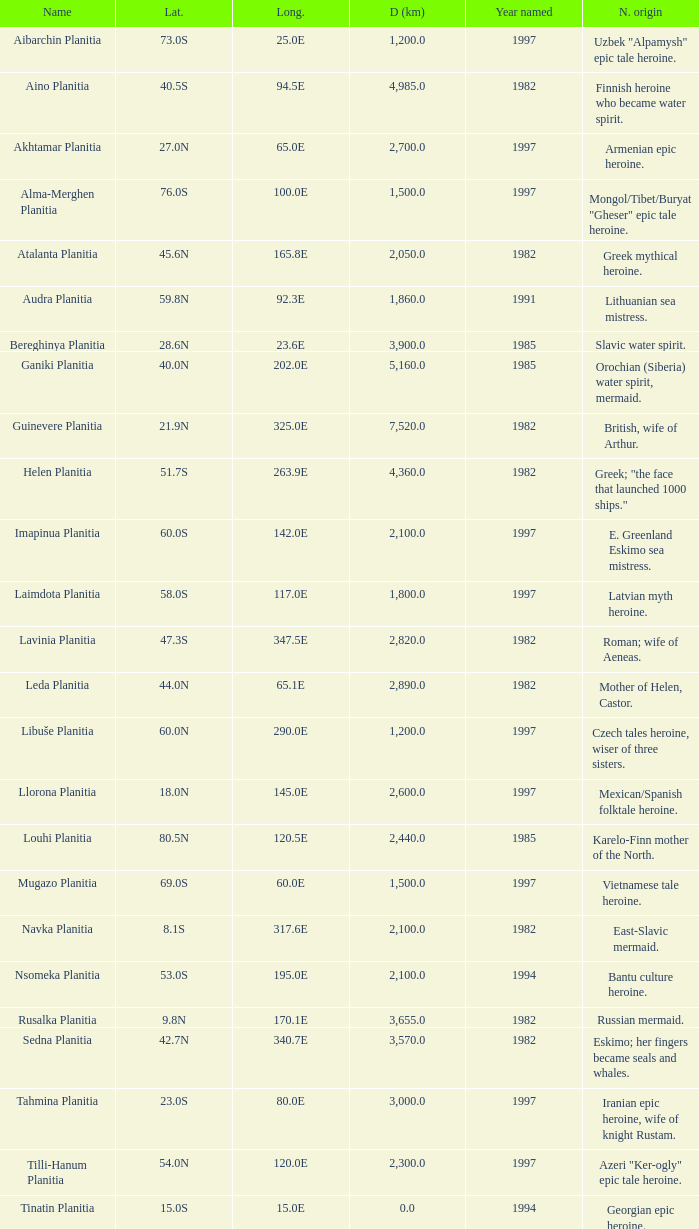What is the diameter (km) of longitude 170.1e 3655.0. 